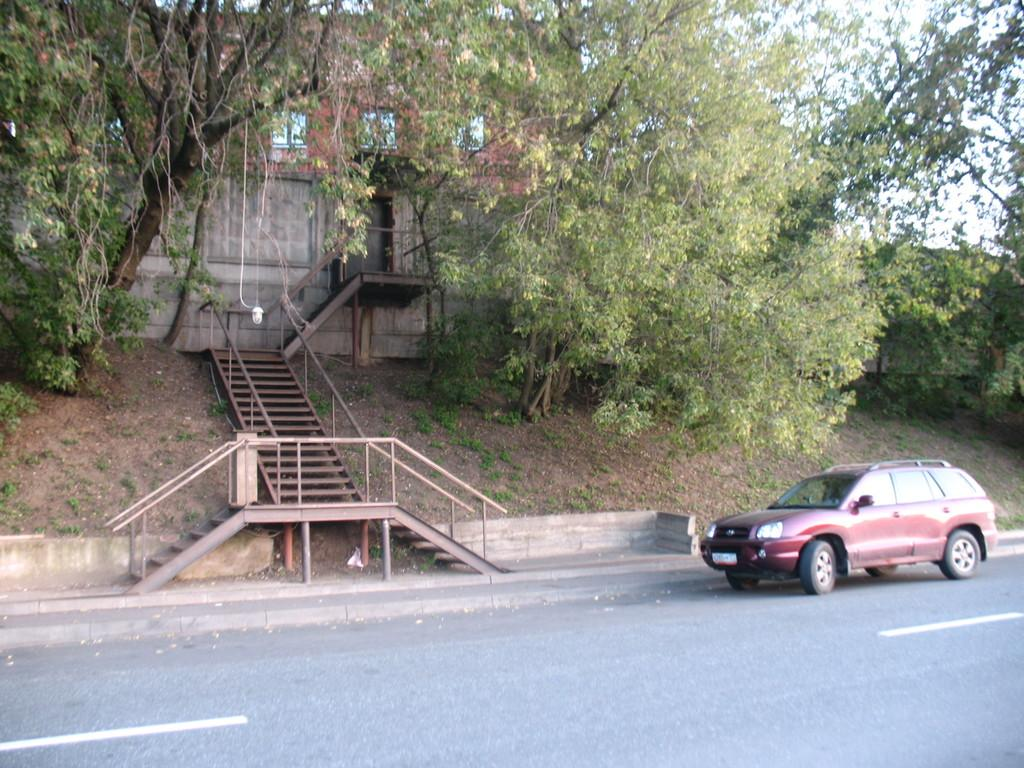What is located in the foreground of the image? There is a vehicle on the road in the foreground of the image. What architectural feature can be seen in the background of the image? There are stairs in the background of the image. What type of vegetation is visible in the background of the image? There are trees in the background of the image. What structure is present in the background of the image? There is a building in the background of the image. What part of the natural environment is visible in the background of the image? The sky is visible in the background of the image. What type of celery is being used to replace the vehicle's horn in the image? There is no celery present in the image, and the vehicle's horn is not being replaced by any vegetable. 